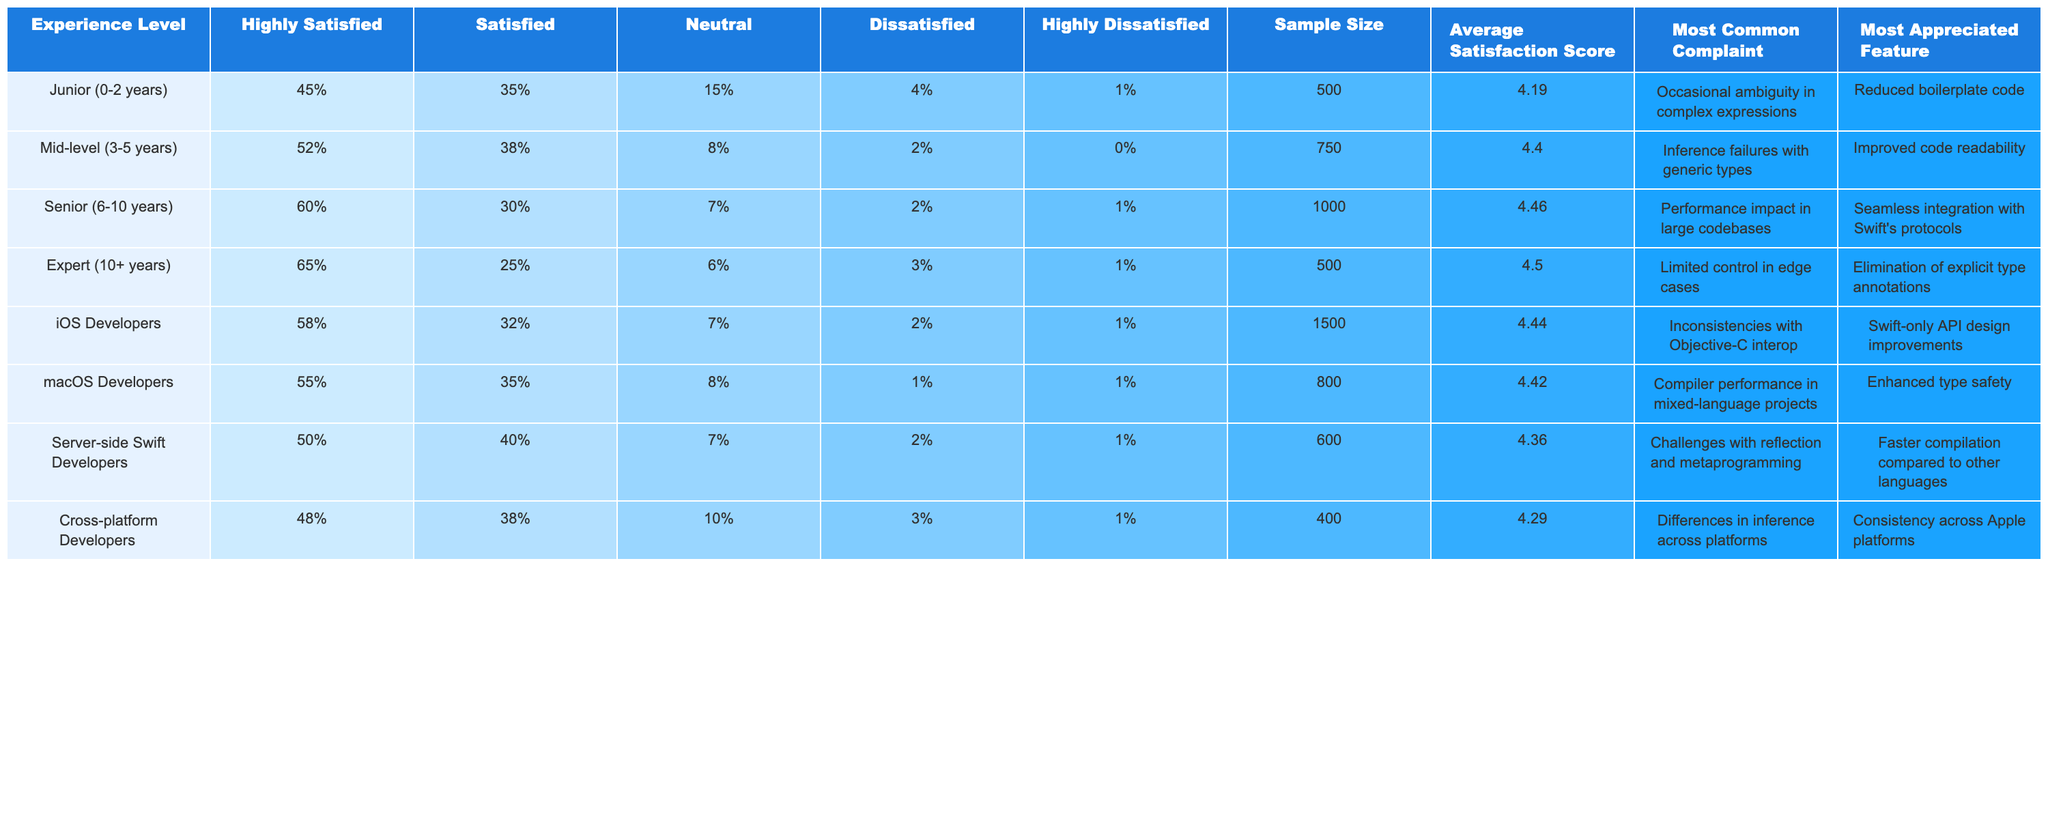What is the sample size for iOS Developers? The table shows a specific column for Sample Size, and for iOS Developers, the value listed is 1500.
Answer: 1500 Which experience level has the highest percentage of "Highly Satisfied" respondents? By comparing the "Highly Satisfied" percentages across experience levels, Senior (6-10 years) with 60% has the highest value.
Answer: Senior (6-10 years) What is the average satisfaction score for Mid-level Developers? The table contains an "Average Satisfaction Score" column, and for Mid-level (3-5 years) Developers, the average score is noted as 4.40.
Answer: 4.40 How many different experience levels are surveyed in total? By counting the rows for each experience level in the table, there are a total of 6 different experience levels listed.
Answer: 6 What percentage of Junior Developers are either dissatisfied or highly dissatisfied? The "Dissatisfied" and "Highly Dissatisfied" percentages for Junior Developers are found in their respective columns as 4% and 1%. Adding these gives 4% + 1% = 5%.
Answer: 5% Which experience level has the most common complaint related to ambiguity in expressions? Referring to the "Most Common Complaint" column, it is listed for Junior Developers, which indicates that this experience level has the complaint regarding occasional ambiguity in complex expressions.
Answer: Junior (0-2 years) Is there any experience level that reports 0% in the "Highly Dissatisfied" category? By checking the table, it can be confirmed that Mid-level (3-5 years) Developers report 0% in the "Highly Dissatisfied" category.
Answer: Yes What is the difference in average satisfaction scores between Senior and Junior Developers? The average satisfaction score for Senior Developers is 4.46, and for Junior Developers, it is 4.19. The difference is calculated as 4.46 - 4.19 = 0.27.
Answer: 0.27 What complaint is most appreciated by Server-side Swift Developers? In the "Most Appreciated Feature" section for Server-side Swift Developers, the feature noted is faster compilation compared to other languages.
Answer: Faster compilation Which developer group has the lowest average satisfaction score? By checking each group's average satisfaction score, Cross-platform Developers have the lowest score at 4.29.
Answer: Cross-platform Developers 